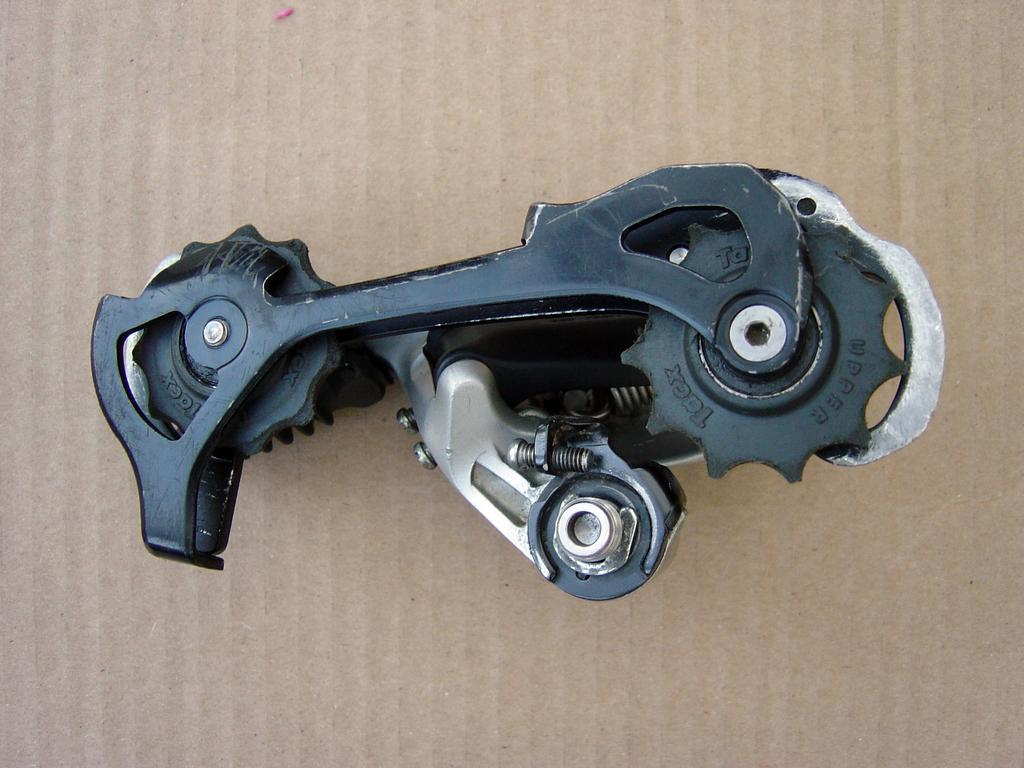What type of object is in the image? There is an instrument in the image. Can you describe the appearance of the instrument? The instrument resembles a gear or a tool. Where is the instrument located in the image? The instrument is on a cardboard sheet. What type of joke is being told by the letters in the image? There are no letters or jokes present in the image; it features an instrument on a cardboard sheet. Can you describe the iron used to press the cardboard sheet in the image? There is no iron present in the image; it only shows an instrument on a cardboard sheet. 